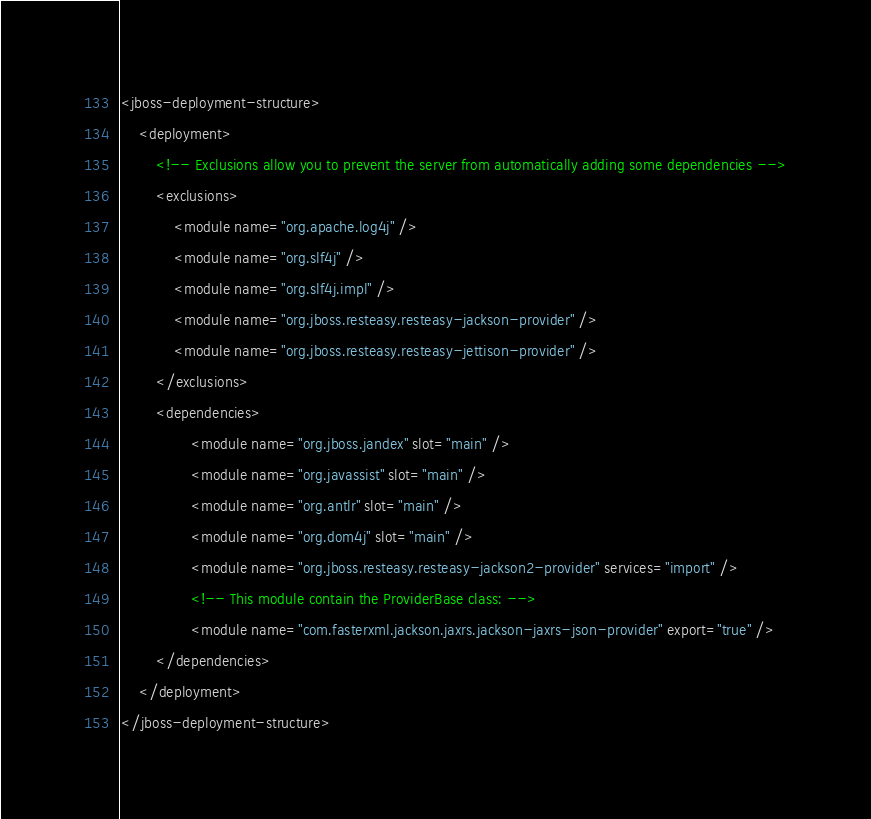Convert code to text. <code><loc_0><loc_0><loc_500><loc_500><_XML_><jboss-deployment-structure>
	<deployment>
		<!-- Exclusions allow you to prevent the server from automatically adding some dependencies -->
		<exclusions>
			<module name="org.apache.log4j" />
			<module name="org.slf4j" />
			<module name="org.slf4j.impl" />
			<module name="org.jboss.resteasy.resteasy-jackson-provider" />
			<module name="org.jboss.resteasy.resteasy-jettison-provider" />
		</exclusions>
		<dependencies>
			    <module name="org.jboss.jandex" slot="main" />
                <module name="org.javassist" slot="main" />
                <module name="org.antlr" slot="main" />
                <module name="org.dom4j" slot="main" />
                <module name="org.jboss.resteasy.resteasy-jackson2-provider" services="import" />
                <!-- This module contain the ProviderBase class: -->
                <module name="com.fasterxml.jackson.jaxrs.jackson-jaxrs-json-provider" export="true" />
		</dependencies>
	</deployment>
</jboss-deployment-structure>

</code> 